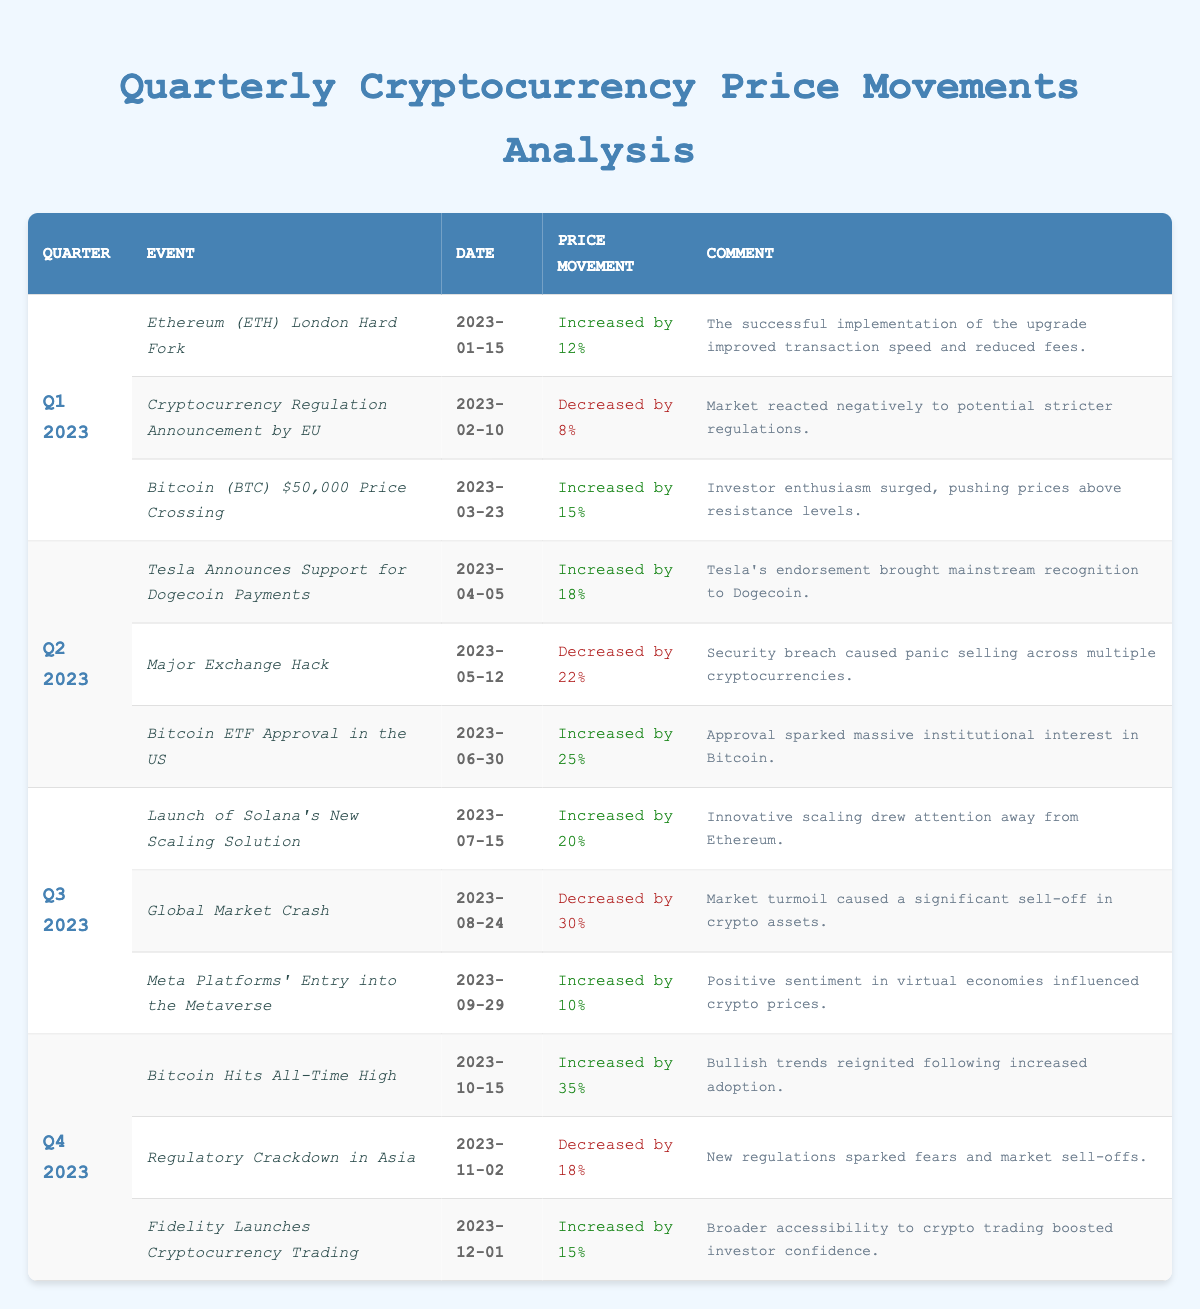What was the price movement of Bitcoin on March 23, 2023? The table indicates that on March 23, 2023, Bitcoin (BTC) experienced a price increase of 15% due to investor enthusiasm.
Answer: Increased by 15% Which quarter had the highest price increase in cryptocurrency? The table shows that Q4 2023 had the highest single price increase of 35% when Bitcoin hit its all-time high.
Answer: Q4 2023 How many events resulted in a price decrease across all quarters? By counting the events from the table, there are three occurrences where the price decreased: February 10, 2023 (8%), May 12, 2023 (22%), and November 2, 2023 (18%).
Answer: 3 What is the average price movement percentage for Q2 2023? For Q2 2023: The price movements were +18%, -22%, and +25%. Calculating the average: (18 - 22 + 25) / 3 = 21 / 3 = 7%.
Answer: 7% Did the price movement following the announcement of the Tesla Dogecoin payment support have a more significant impact compared to the Major Exchange Hack? The price movement following Tesla's announcement was +18%, while the Major Exchange Hack caused a -22% movement. The negative impact was indeed more significant.
Answer: Yes What were the total price movements of all events in Q1 2023? In Q1 2023, the price movements were +12% (ETH hard fork), -8% (EU regulation announcement), and +15% (BTC crossing $50,000). Calculating the total: 12 - 8 + 15 = 19%.
Answer: 19% Which event in Q3 2023 resulted in the largest price decrease, and what was the percentage? The largest price decrease in Q3 2023 was due to the Global Market Crash on August 24, 2023, which led to a -30% movement.
Answer: Global Market Crash, -30% What event in Q4 2023 had the most positive comment regarding investor confidence? The event mentioned with the most positive comment in Q4 2023 regarding investor confidence is the launch of cryptocurrency trading by Fidelity, described as boosting broader accessibility and confidence.
Answer: Fidelity Launches Cryptocurrency Trading What was the price movement trend throughout Q3 2023? In Q3 2023, the events include a +20% increase (Solana's launch), a -30% decrease (Global market crash), and a +10% increase (Meta's entry), yielding a mixed trend with significant volatility.
Answer: Mixed trend with volatility 